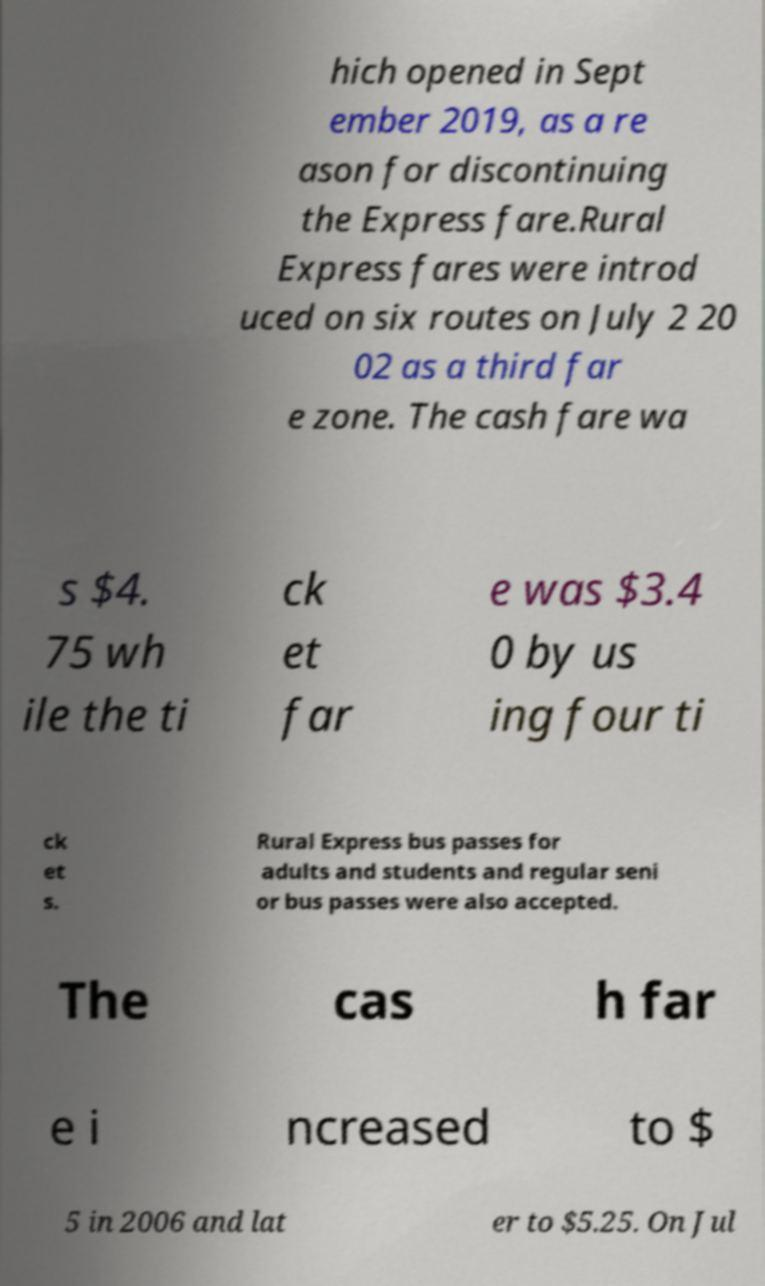I need the written content from this picture converted into text. Can you do that? hich opened in Sept ember 2019, as a re ason for discontinuing the Express fare.Rural Express fares were introd uced on six routes on July 2 20 02 as a third far e zone. The cash fare wa s $4. 75 wh ile the ti ck et far e was $3.4 0 by us ing four ti ck et s. Rural Express bus passes for adults and students and regular seni or bus passes were also accepted. The cas h far e i ncreased to $ 5 in 2006 and lat er to $5.25. On Jul 